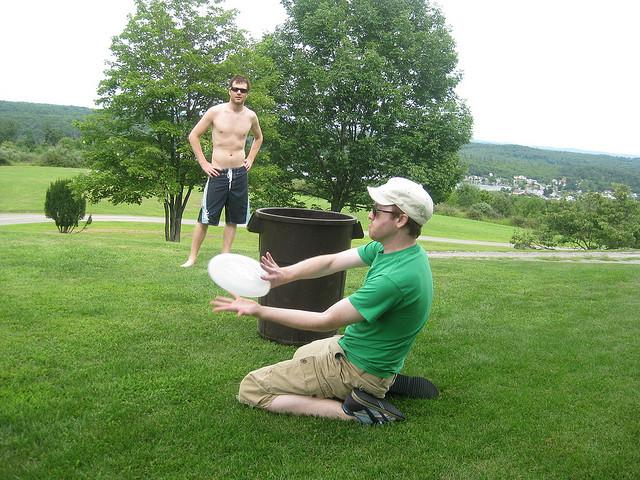What is the man wearing a hat doing? catching frisbee 